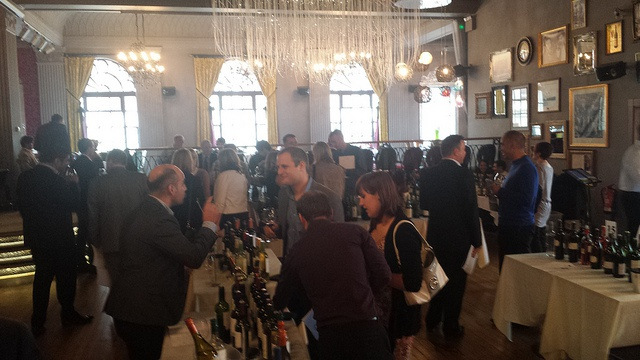Describe the objects in this image and their specific colors. I can see people in lightgray, black, gray, and darkgray tones, people in lightgray, black, maroon, and gray tones, people in lightgray, black, gray, and brown tones, bottle in lightgray, black, maroon, and gray tones, and people in lightgray, black, gray, and purple tones in this image. 